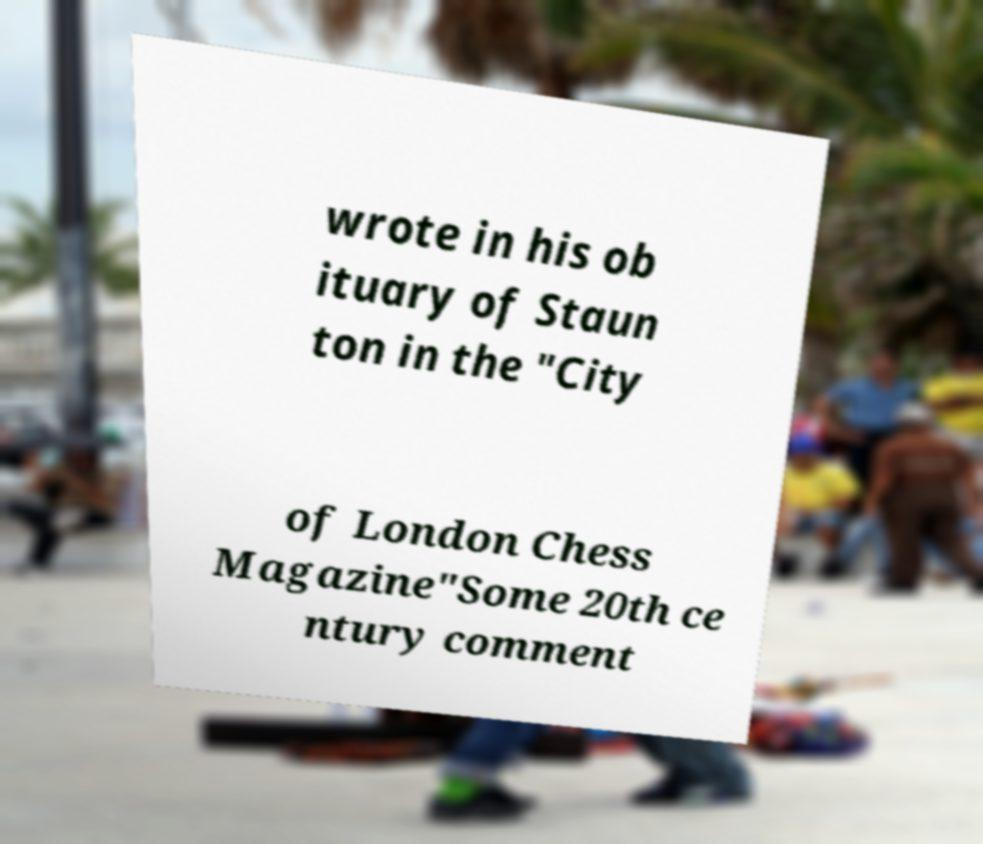Please read and relay the text visible in this image. What does it say? wrote in his ob ituary of Staun ton in the "City of London Chess Magazine"Some 20th ce ntury comment 